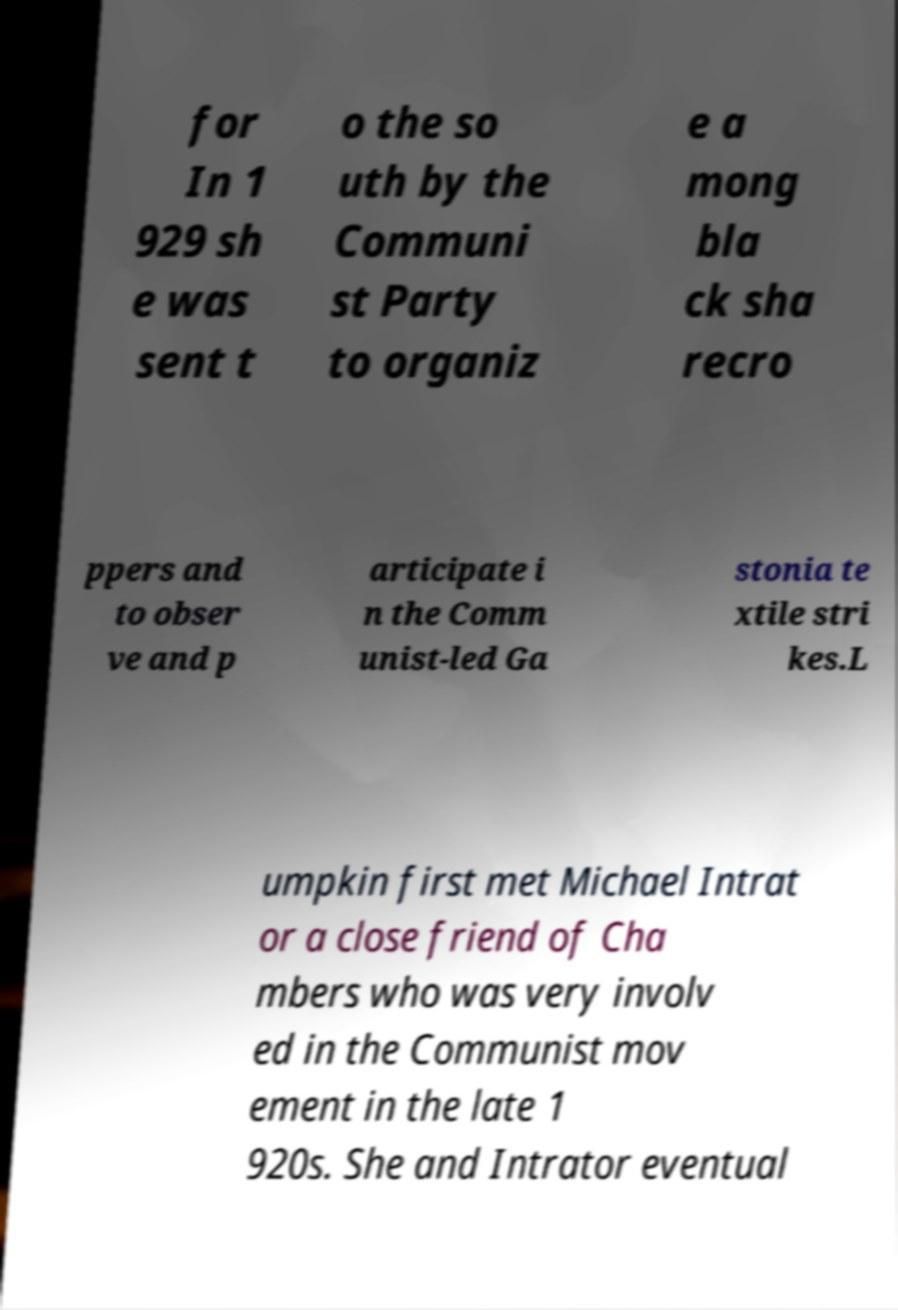Could you assist in decoding the text presented in this image and type it out clearly? for In 1 929 sh e was sent t o the so uth by the Communi st Party to organiz e a mong bla ck sha recro ppers and to obser ve and p articipate i n the Comm unist-led Ga stonia te xtile stri kes.L umpkin first met Michael Intrat or a close friend of Cha mbers who was very involv ed in the Communist mov ement in the late 1 920s. She and Intrator eventual 